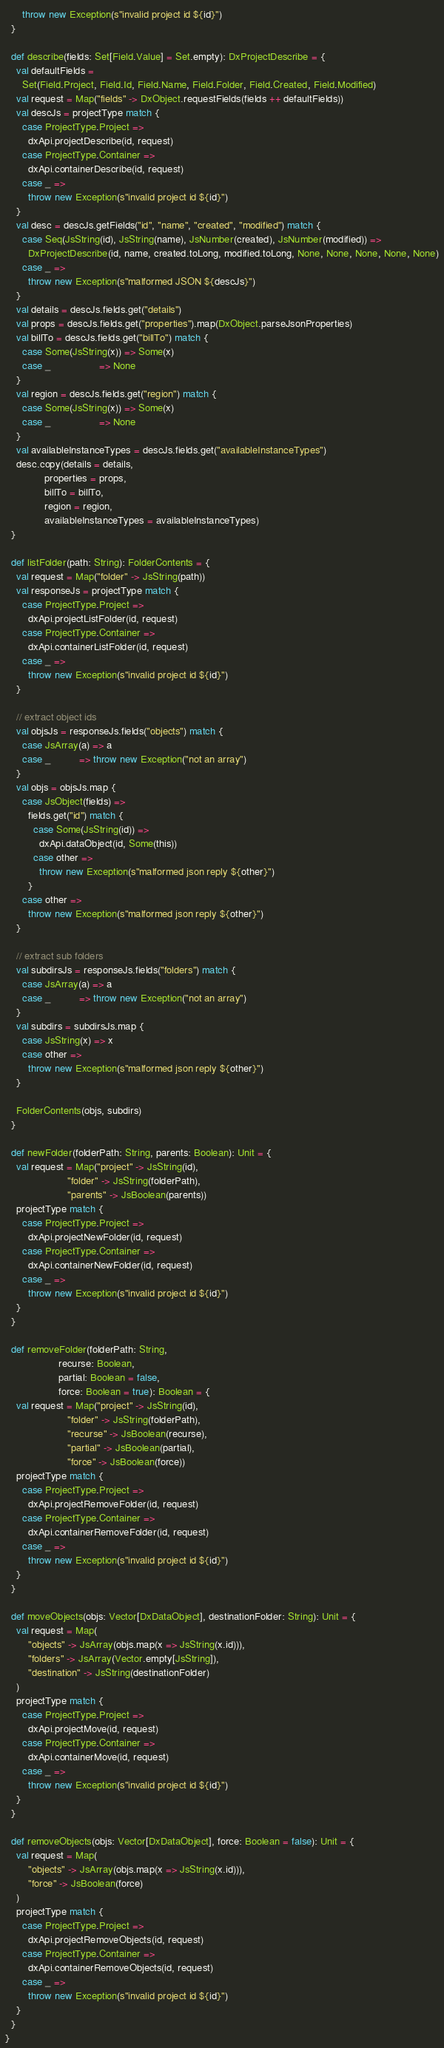Convert code to text. <code><loc_0><loc_0><loc_500><loc_500><_Scala_>      throw new Exception(s"invalid project id ${id}")
  }

  def describe(fields: Set[Field.Value] = Set.empty): DxProjectDescribe = {
    val defaultFields =
      Set(Field.Project, Field.Id, Field.Name, Field.Folder, Field.Created, Field.Modified)
    val request = Map("fields" -> DxObject.requestFields(fields ++ defaultFields))
    val descJs = projectType match {
      case ProjectType.Project =>
        dxApi.projectDescribe(id, request)
      case ProjectType.Container =>
        dxApi.containerDescribe(id, request)
      case _ =>
        throw new Exception(s"invalid project id ${id}")
    }
    val desc = descJs.getFields("id", "name", "created", "modified") match {
      case Seq(JsString(id), JsString(name), JsNumber(created), JsNumber(modified)) =>
        DxProjectDescribe(id, name, created.toLong, modified.toLong, None, None, None, None, None)
      case _ =>
        throw new Exception(s"malformed JSON ${descJs}")
    }
    val details = descJs.fields.get("details")
    val props = descJs.fields.get("properties").map(DxObject.parseJsonProperties)
    val billTo = descJs.fields.get("billTo") match {
      case Some(JsString(x)) => Some(x)
      case _                 => None
    }
    val region = descJs.fields.get("region") match {
      case Some(JsString(x)) => Some(x)
      case _                 => None
    }
    val availableInstanceTypes = descJs.fields.get("availableInstanceTypes")
    desc.copy(details = details,
              properties = props,
              billTo = billTo,
              region = region,
              availableInstanceTypes = availableInstanceTypes)
  }

  def listFolder(path: String): FolderContents = {
    val request = Map("folder" -> JsString(path))
    val responseJs = projectType match {
      case ProjectType.Project =>
        dxApi.projectListFolder(id, request)
      case ProjectType.Container =>
        dxApi.containerListFolder(id, request)
      case _ =>
        throw new Exception(s"invalid project id ${id}")
    }

    // extract object ids
    val objsJs = responseJs.fields("objects") match {
      case JsArray(a) => a
      case _          => throw new Exception("not an array")
    }
    val objs = objsJs.map {
      case JsObject(fields) =>
        fields.get("id") match {
          case Some(JsString(id)) =>
            dxApi.dataObject(id, Some(this))
          case other =>
            throw new Exception(s"malformed json reply ${other}")
        }
      case other =>
        throw new Exception(s"malformed json reply ${other}")
    }

    // extract sub folders
    val subdirsJs = responseJs.fields("folders") match {
      case JsArray(a) => a
      case _          => throw new Exception("not an array")
    }
    val subdirs = subdirsJs.map {
      case JsString(x) => x
      case other =>
        throw new Exception(s"malformed json reply ${other}")
    }

    FolderContents(objs, subdirs)
  }

  def newFolder(folderPath: String, parents: Boolean): Unit = {
    val request = Map("project" -> JsString(id),
                      "folder" -> JsString(folderPath),
                      "parents" -> JsBoolean(parents))
    projectType match {
      case ProjectType.Project =>
        dxApi.projectNewFolder(id, request)
      case ProjectType.Container =>
        dxApi.containerNewFolder(id, request)
      case _ =>
        throw new Exception(s"invalid project id ${id}")
    }
  }

  def removeFolder(folderPath: String,
                   recurse: Boolean,
                   partial: Boolean = false,
                   force: Boolean = true): Boolean = {
    val request = Map("project" -> JsString(id),
                      "folder" -> JsString(folderPath),
                      "recurse" -> JsBoolean(recurse),
                      "partial" -> JsBoolean(partial),
                      "force" -> JsBoolean(force))
    projectType match {
      case ProjectType.Project =>
        dxApi.projectRemoveFolder(id, request)
      case ProjectType.Container =>
        dxApi.containerRemoveFolder(id, request)
      case _ =>
        throw new Exception(s"invalid project id ${id}")
    }
  }

  def moveObjects(objs: Vector[DxDataObject], destinationFolder: String): Unit = {
    val request = Map(
        "objects" -> JsArray(objs.map(x => JsString(x.id))),
        "folders" -> JsArray(Vector.empty[JsString]),
        "destination" -> JsString(destinationFolder)
    )
    projectType match {
      case ProjectType.Project =>
        dxApi.projectMove(id, request)
      case ProjectType.Container =>
        dxApi.containerMove(id, request)
      case _ =>
        throw new Exception(s"invalid project id ${id}")
    }
  }

  def removeObjects(objs: Vector[DxDataObject], force: Boolean = false): Unit = {
    val request = Map(
        "objects" -> JsArray(objs.map(x => JsString(x.id))),
        "force" -> JsBoolean(force)
    )
    projectType match {
      case ProjectType.Project =>
        dxApi.projectRemoveObjects(id, request)
      case ProjectType.Container =>
        dxApi.containerRemoveObjects(id, request)
      case _ =>
        throw new Exception(s"invalid project id ${id}")
    }
  }
}
</code> 